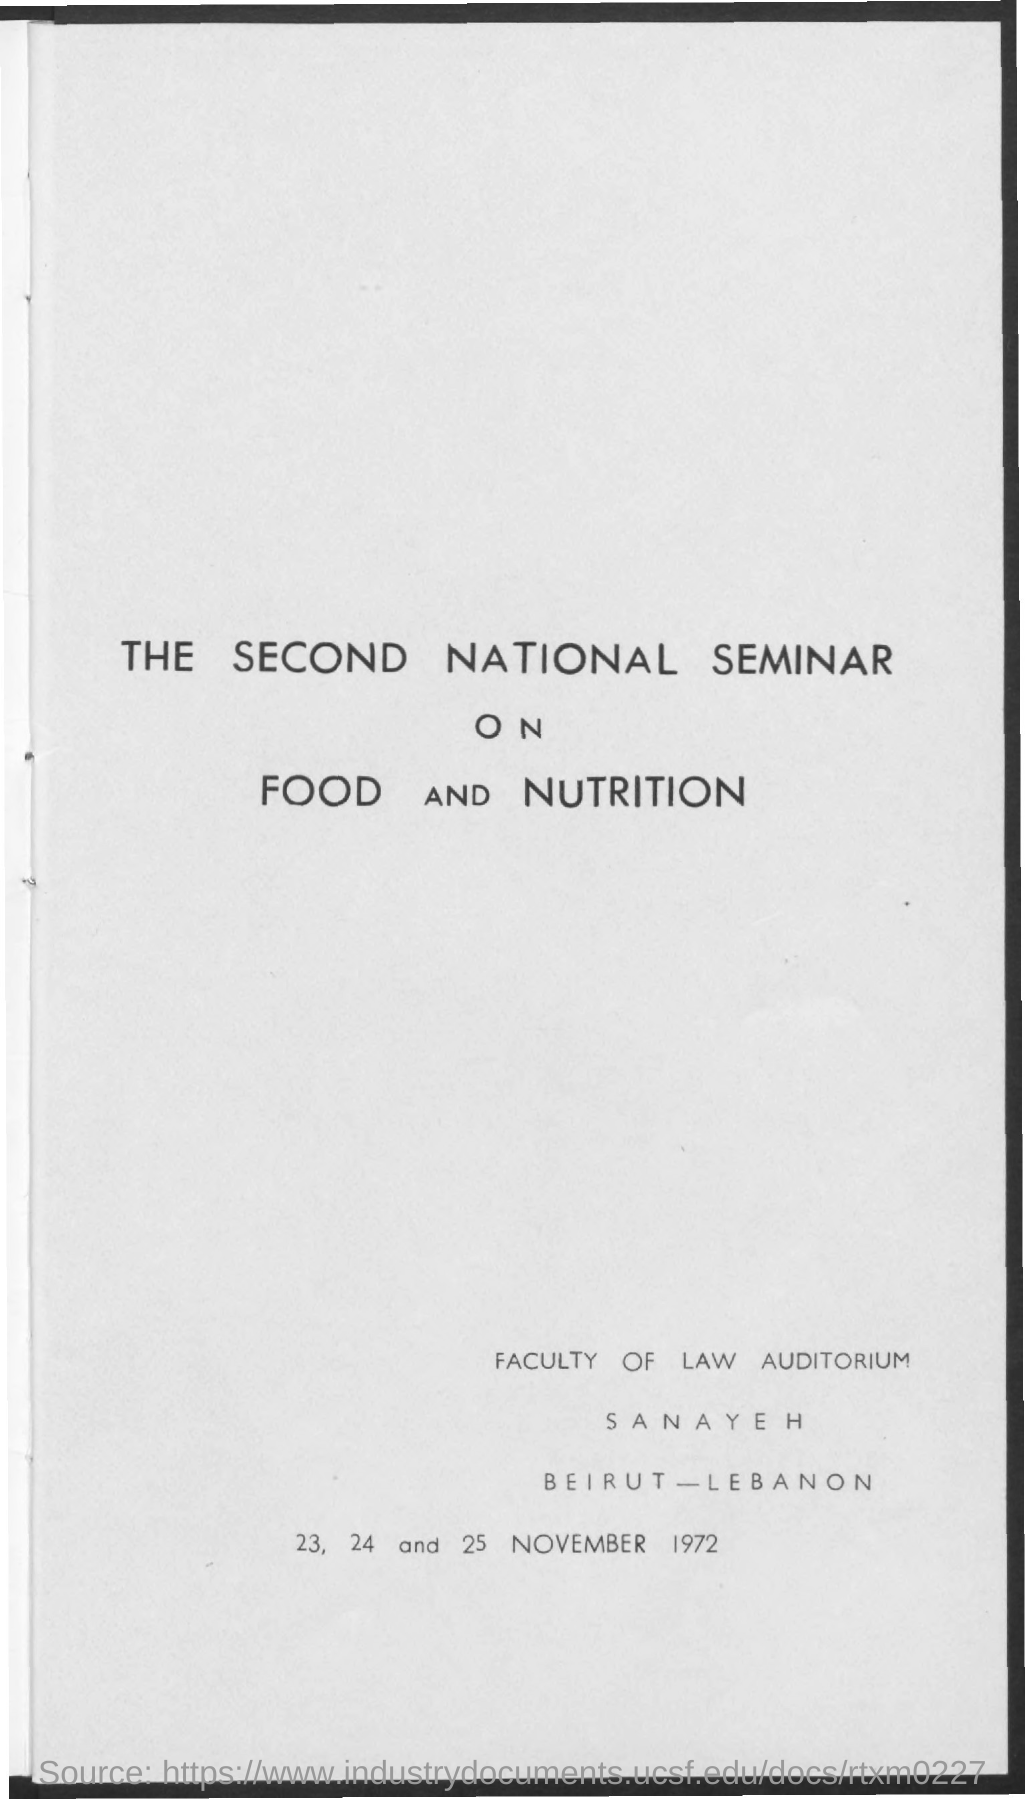Highlight a few significant elements in this photo. The title of the document is "The Second National Seminar on Food and Nutrition. 